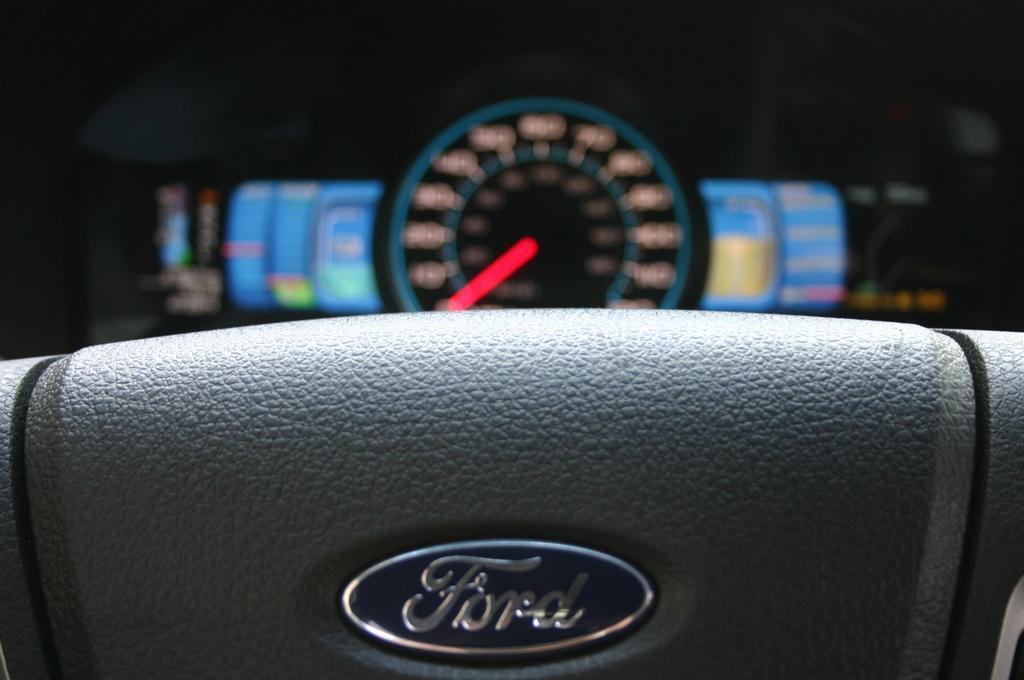Describe this image in one or two sentences. In this picture I can see there is a steering wheel and it has a logo and there is a speedometer in the backdrop. There is a indicator and lights in the speedometer. 